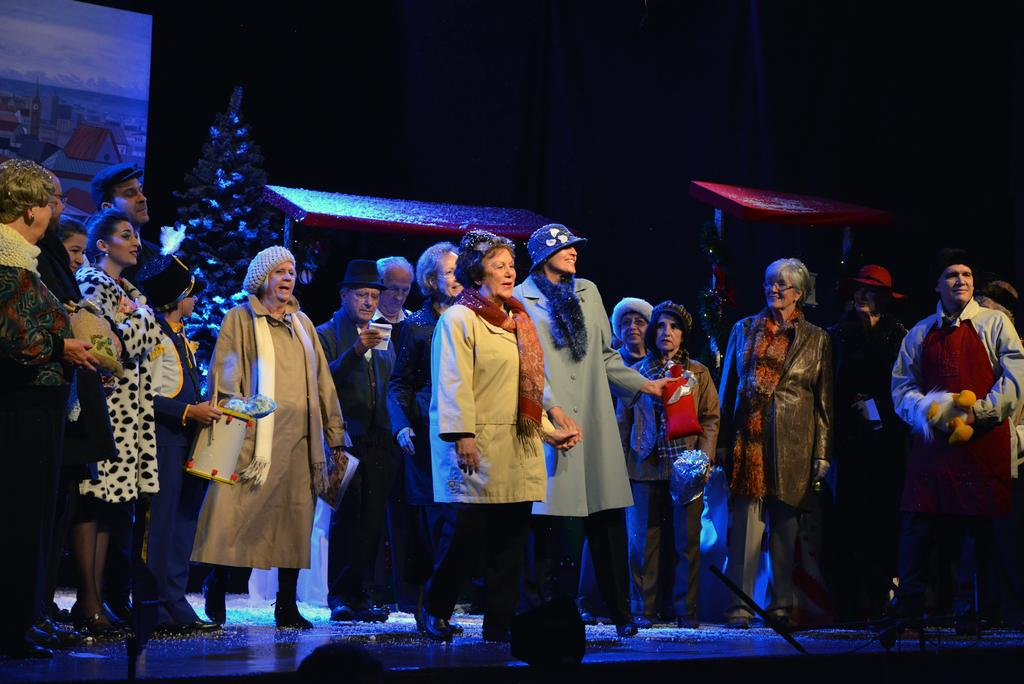What is happening in the image? There are many people standing on the floor in the image. What can be seen in the background of the image? There is a tree in the background of the image. How would you describe the lighting in the image? The background of the image is dark. What type of grass is growing on the slope in the image? There is no slope or grass present in the image; it features people standing on the floor with a tree in the background. 